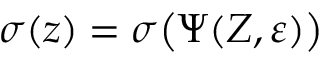<formula> <loc_0><loc_0><loc_500><loc_500>\sigma ( \boldsymbol z ) = \sigma \left ( \Psi ( Z , \varepsilon ) \right )</formula> 